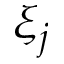<formula> <loc_0><loc_0><loc_500><loc_500>\xi _ { j }</formula> 